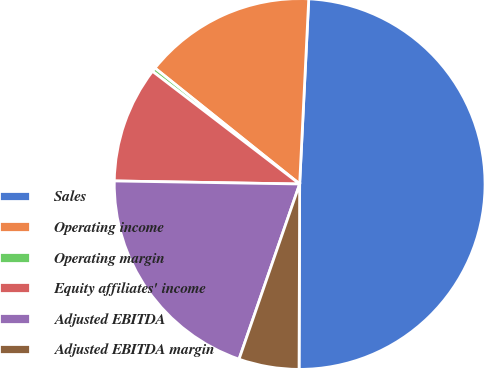<chart> <loc_0><loc_0><loc_500><loc_500><pie_chart><fcel>Sales<fcel>Operating income<fcel>Operating margin<fcel>Equity affiliates' income<fcel>Adjusted EBITDA<fcel>Adjusted EBITDA margin<nl><fcel>49.27%<fcel>15.03%<fcel>0.35%<fcel>10.14%<fcel>19.96%<fcel>5.25%<nl></chart> 